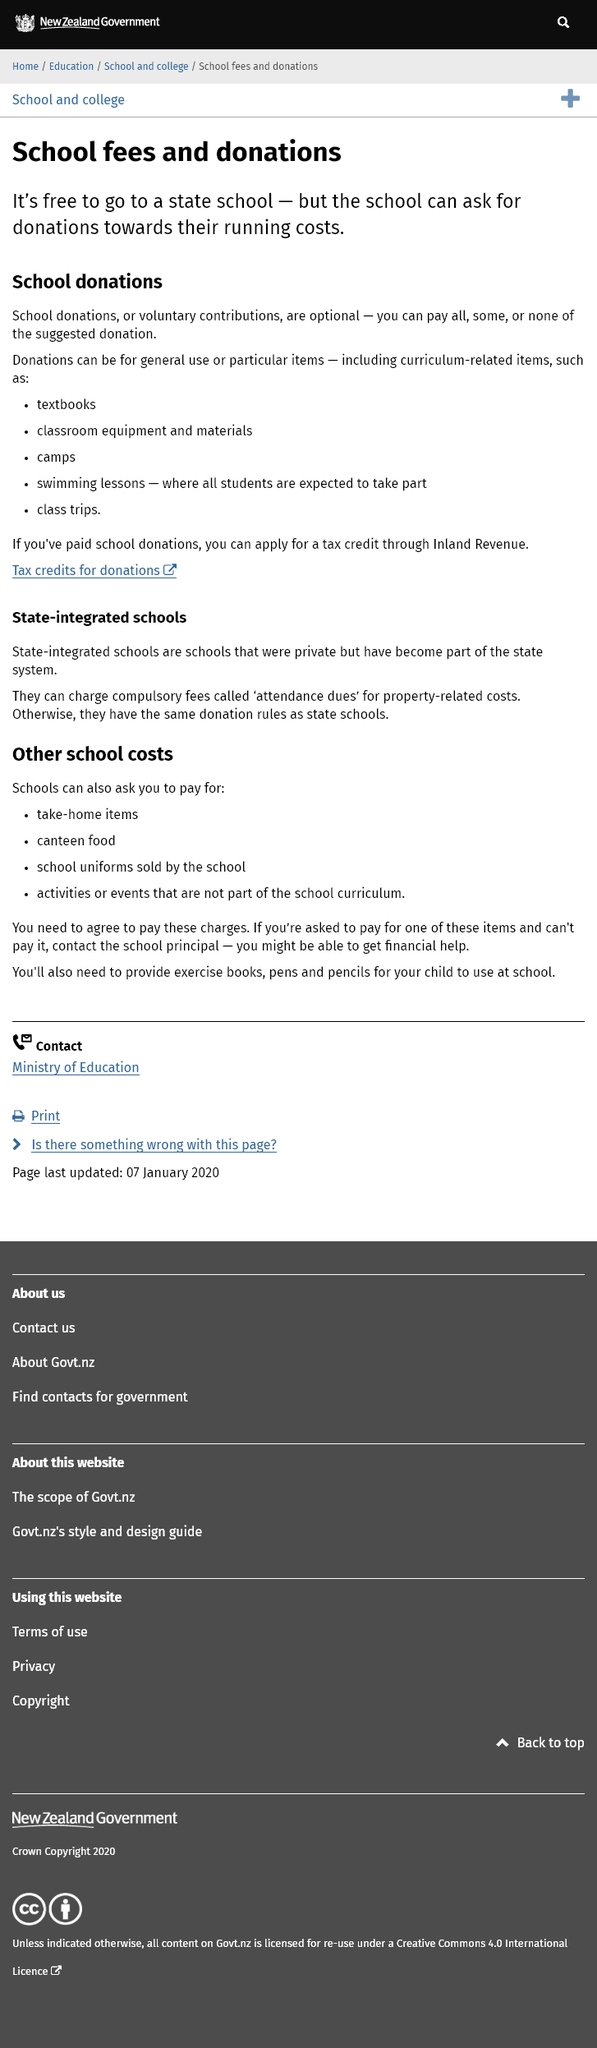Identify some key points in this picture. Declarative: Donations can be used to purchase items such as textbooks, classroom equipment, camps, swimming lessons, and class trips. Yes, it is possible for you to claim tax credits on school donations that you have made, and the process for doing so can be facilitated through the Inland Revenue. The cost of attending a state school is free, but schools may request donations for running expenses. 